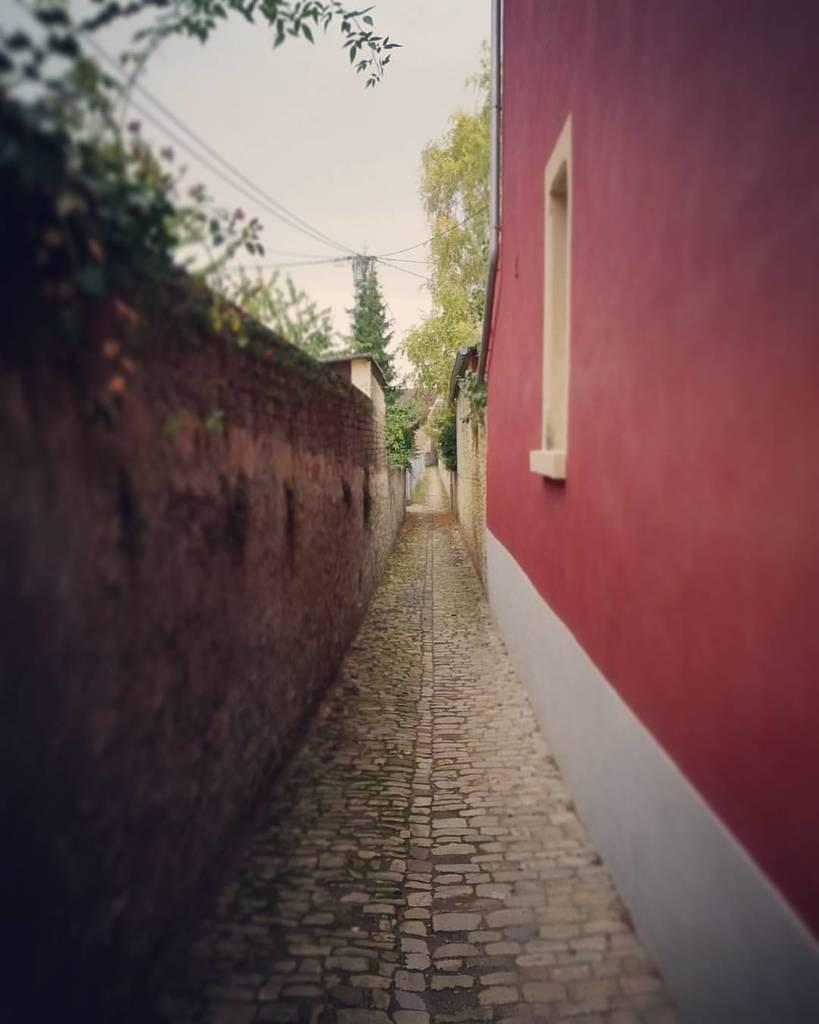What type of path is visible in the image? There is a stone path in the image. What type of structure can be seen in the image? There is a brick wall and a building in the image. What type of infrastructure is present in the image? There are wires in the image. What type of natural elements are present in the image? There are trees in the image. What type of architectural feature can be seen in the background of the image? There is a wall in the background of the image. Can you see a yak grazing on the grass near the building in the image? There is no yak present in the image. What type of farm animals can be seen in the image? There are no farm animals present in the image. 